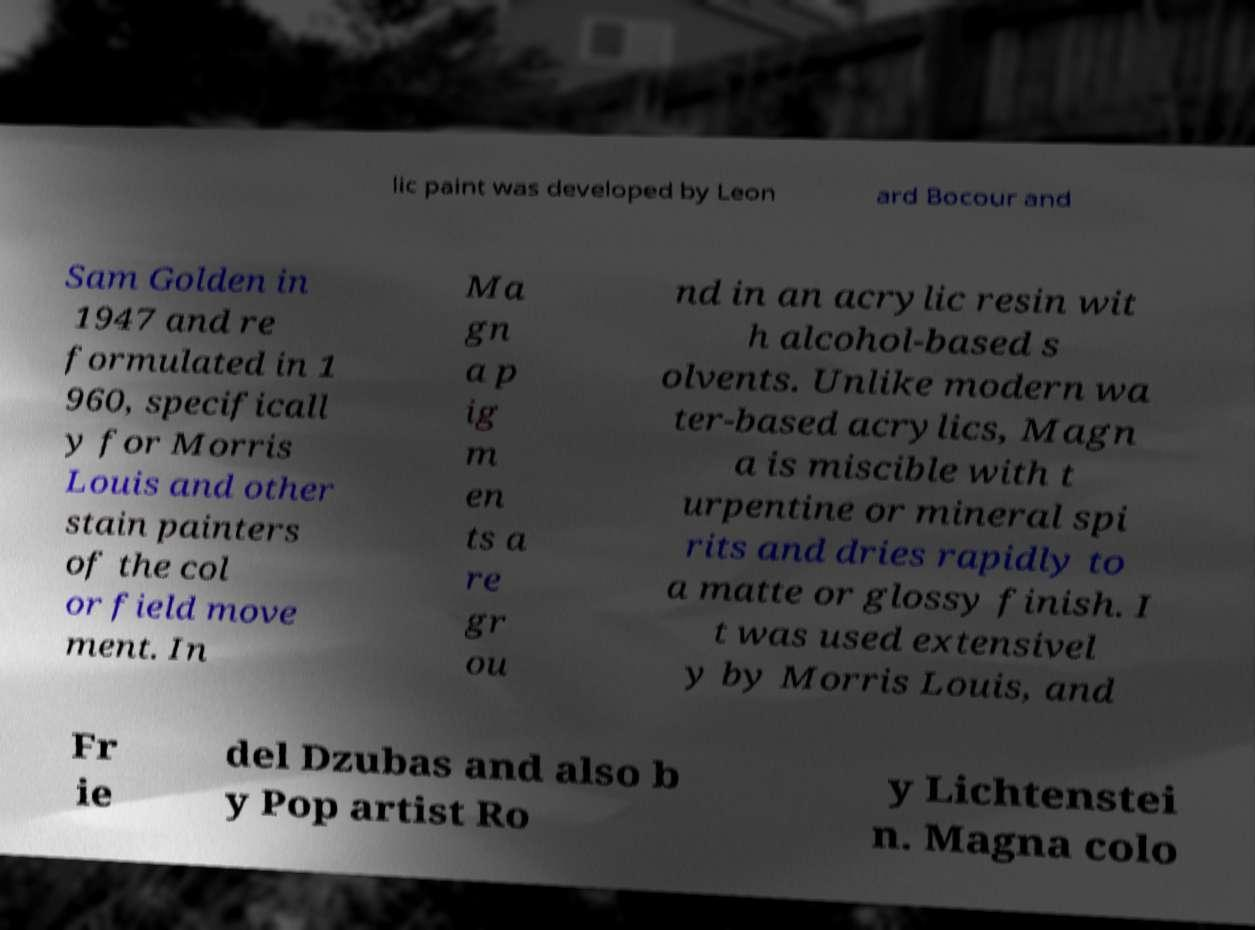I need the written content from this picture converted into text. Can you do that? lic paint was developed by Leon ard Bocour and Sam Golden in 1947 and re formulated in 1 960, specificall y for Morris Louis and other stain painters of the col or field move ment. In Ma gn a p ig m en ts a re gr ou nd in an acrylic resin wit h alcohol-based s olvents. Unlike modern wa ter-based acrylics, Magn a is miscible with t urpentine or mineral spi rits and dries rapidly to a matte or glossy finish. I t was used extensivel y by Morris Louis, and Fr ie del Dzubas and also b y Pop artist Ro y Lichtenstei n. Magna colo 